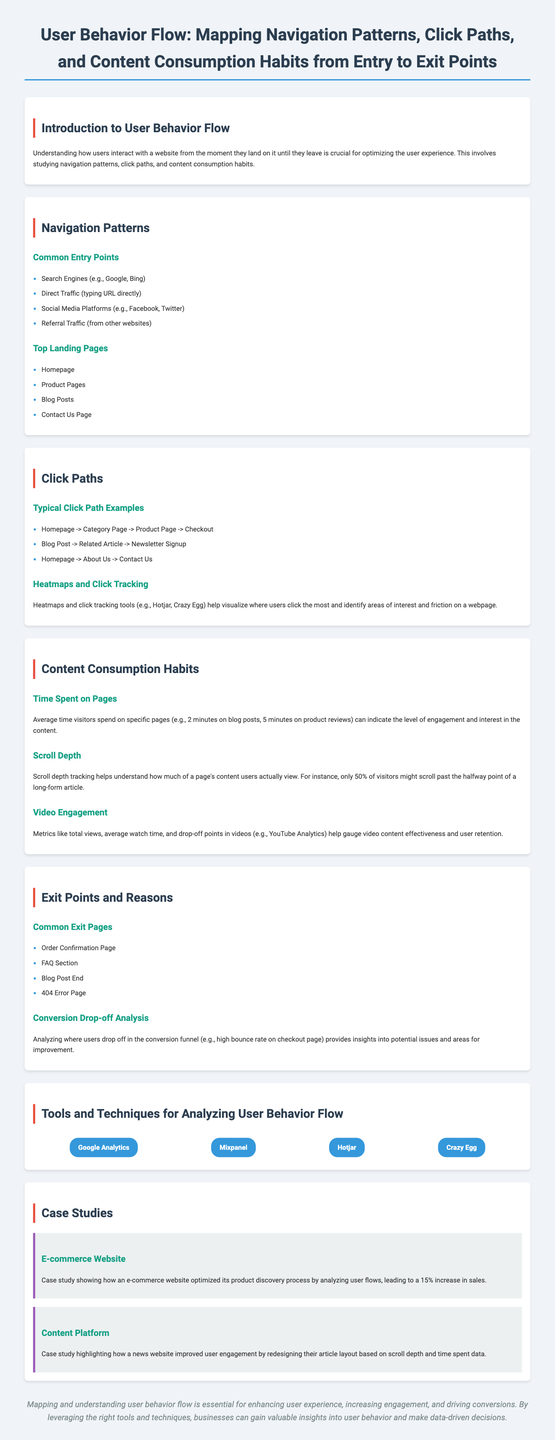what is the title of the infographic? The title is prominently displayed at the top of the document, summarizing the main focus of the infographic.
Answer: User Behavior Flow: Mapping Navigation Patterns, Click Paths, and Content Consumption Habits from Entry to Exit Points what are the common entry points listed? The document lists several common entry points where users enter a website, which can impact navigation patterns.
Answer: Search Engines, Direct Traffic, Social Media Platforms, Referral Traffic how many case studies are presented? The section on case studies provides specific examples that illustrate concepts discussed in the infographic, and it presents a specific number of studies.
Answer: 2 what is the average time spent on blog posts according to the document? The document shares specific metrics about user engagement with content, including the average time spent on specific pages.
Answer: 2 minutes which tool is used for heatmaps and click tracking? The document mentions a couple of tools specifically for visualizing user clicks and interaction on a webpage.
Answer: Hotjar what improvement percentage did the e-commerce website achieve? The case study provides a quantitative outcome based on the analysis conducted, showing the results of the adjustments made.
Answer: 15% what measurement helps understand scroll behavior on a page? The document describes a specific behavior metric that provides insights into content visibility and engagement level.
Answer: Scroll depth what are two common exit pages listed in the document? The document outlines specific pages where users typically leave the website, providing insights into user behavior.
Answer: Order Confirmation Page, 404 Error Page 